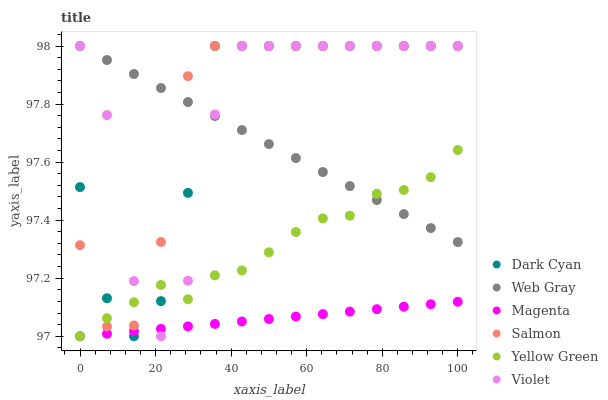Does Magenta have the minimum area under the curve?
Answer yes or no. Yes. Does Salmon have the maximum area under the curve?
Answer yes or no. Yes. Does Yellow Green have the minimum area under the curve?
Answer yes or no. No. Does Yellow Green have the maximum area under the curve?
Answer yes or no. No. Is Web Gray the smoothest?
Answer yes or no. Yes. Is Violet the roughest?
Answer yes or no. Yes. Is Yellow Green the smoothest?
Answer yes or no. No. Is Yellow Green the roughest?
Answer yes or no. No. Does Yellow Green have the lowest value?
Answer yes or no. Yes. Does Salmon have the lowest value?
Answer yes or no. No. Does Dark Cyan have the highest value?
Answer yes or no. Yes. Does Yellow Green have the highest value?
Answer yes or no. No. Is Magenta less than Web Gray?
Answer yes or no. Yes. Is Web Gray greater than Magenta?
Answer yes or no. Yes. Does Dark Cyan intersect Magenta?
Answer yes or no. Yes. Is Dark Cyan less than Magenta?
Answer yes or no. No. Is Dark Cyan greater than Magenta?
Answer yes or no. No. Does Magenta intersect Web Gray?
Answer yes or no. No. 